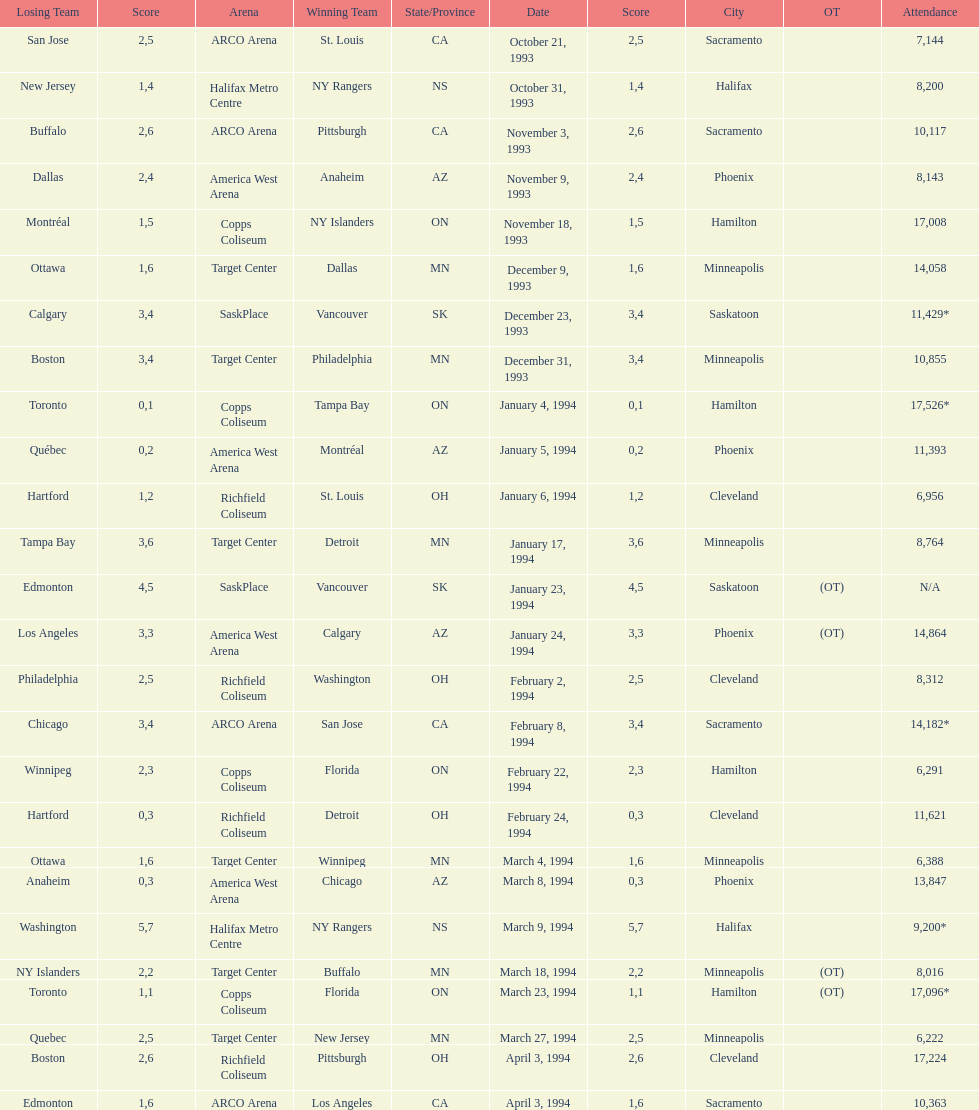How many neutral site games resulted in overtime (ot)? 4. 